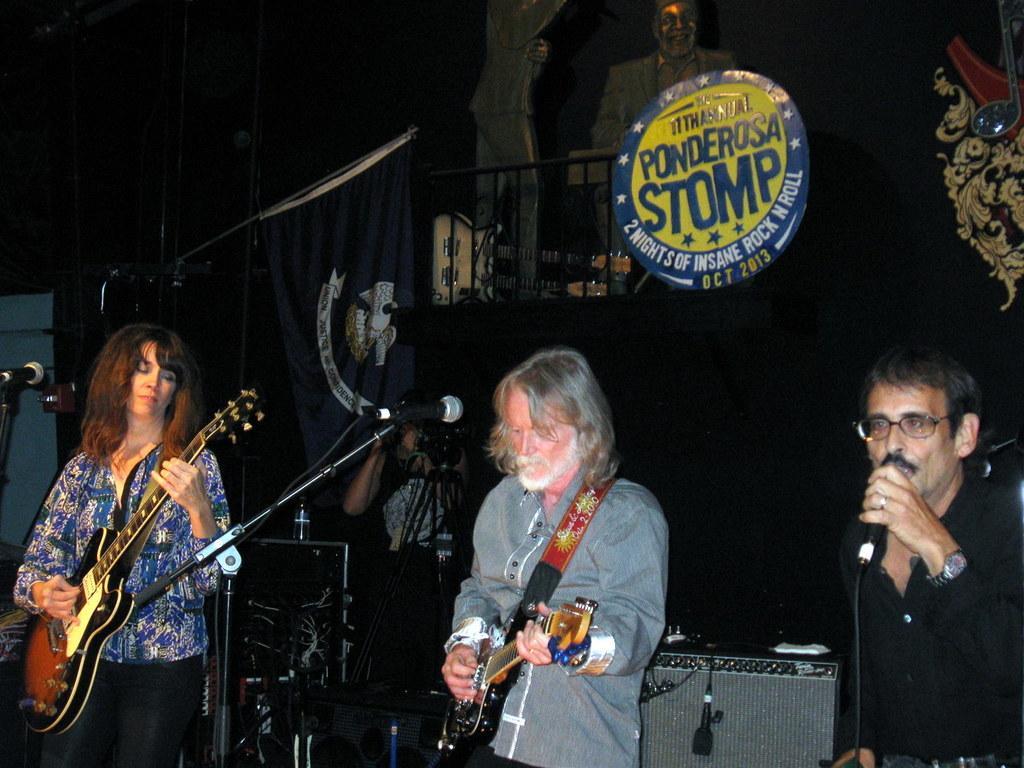How would you summarize this image in a sentence or two? in this picture we can see a person standing on the stage and playing guitar, and at side a man is standing and singing and holding a microphone in his hand, and here a woman is standing and playing guitar, and at back a person is standing, and here at the top there is the statue. 